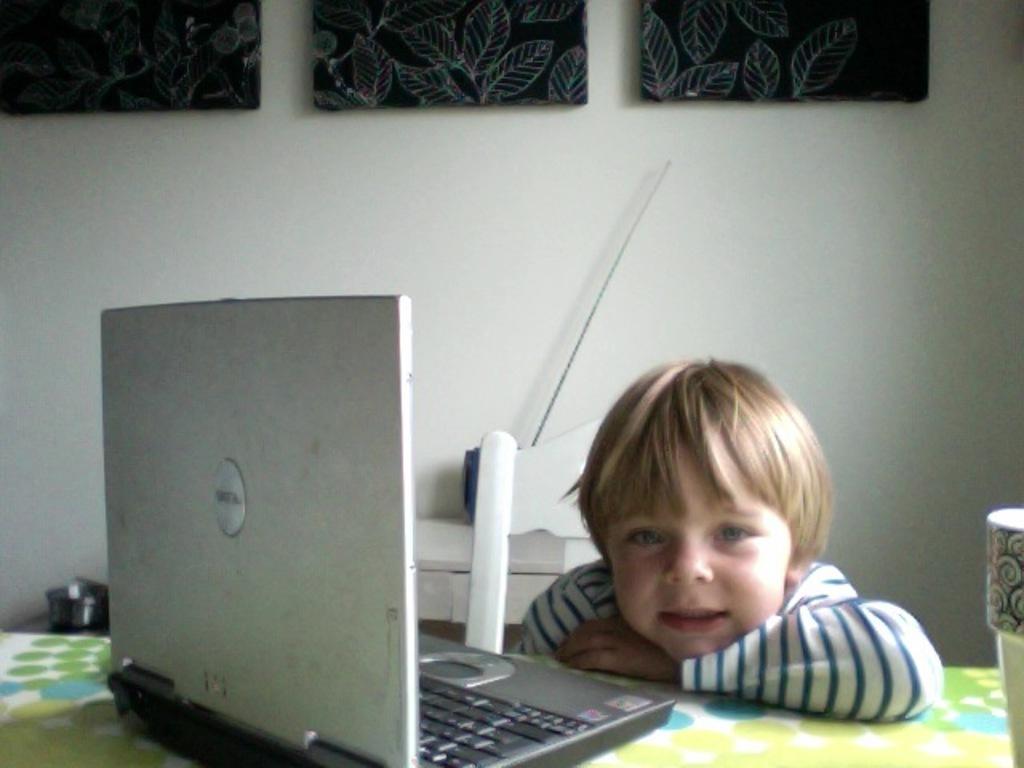How would you summarize this image in a sentence or two? This picture is clicked inside the room. Here, we see a boy in white t-shirt is sitting on chair. In front of him, we see a table on which laptop and cup are placed. Behind them, we see a white wall and three black photo frames on white wall. 